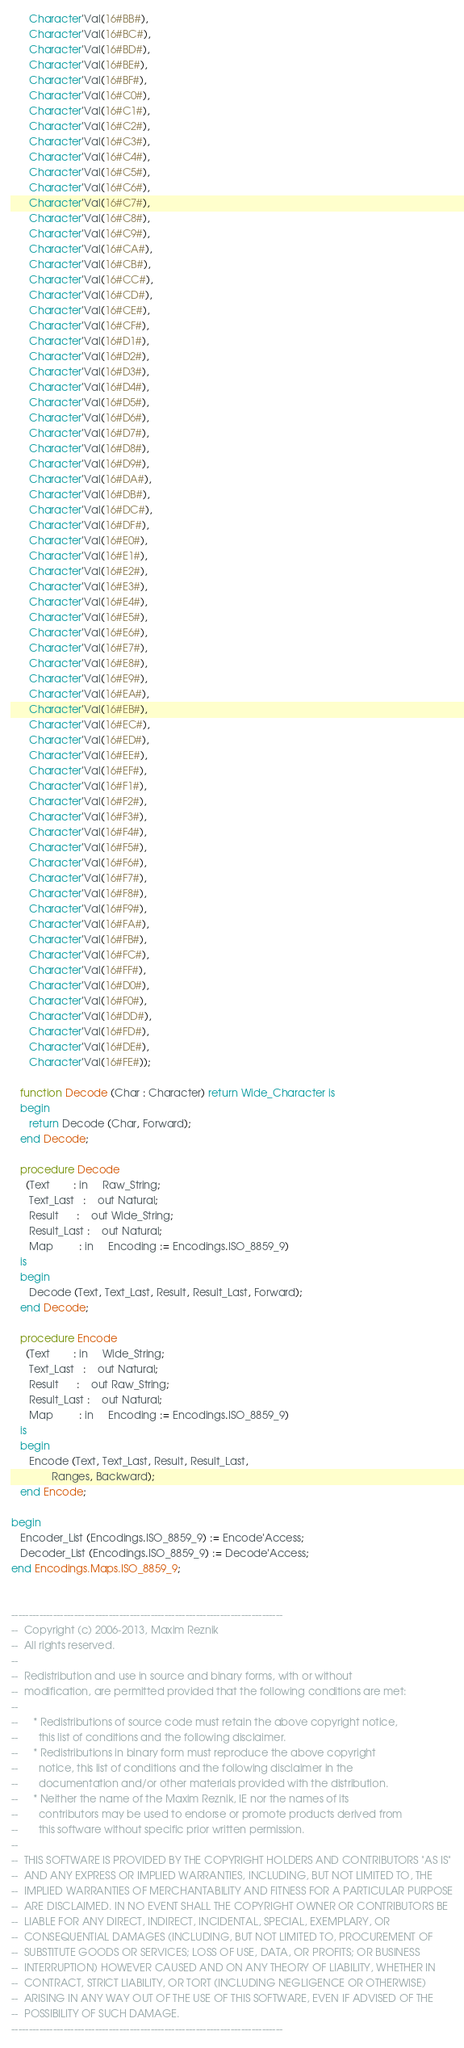Convert code to text. <code><loc_0><loc_0><loc_500><loc_500><_Ada_>      Character'Val(16#BB#),
      Character'Val(16#BC#),
      Character'Val(16#BD#),
      Character'Val(16#BE#),
      Character'Val(16#BF#),
      Character'Val(16#C0#),
      Character'Val(16#C1#),
      Character'Val(16#C2#),
      Character'Val(16#C3#),
      Character'Val(16#C4#),
      Character'Val(16#C5#),
      Character'Val(16#C6#),
      Character'Val(16#C7#),
      Character'Val(16#C8#),
      Character'Val(16#C9#),
      Character'Val(16#CA#),
      Character'Val(16#CB#),
      Character'Val(16#CC#),
      Character'Val(16#CD#),
      Character'Val(16#CE#),
      Character'Val(16#CF#),
      Character'Val(16#D1#),
      Character'Val(16#D2#),
      Character'Val(16#D3#),
      Character'Val(16#D4#),
      Character'Val(16#D5#),
      Character'Val(16#D6#),
      Character'Val(16#D7#),
      Character'Val(16#D8#),
      Character'Val(16#D9#),
      Character'Val(16#DA#),
      Character'Val(16#DB#),
      Character'Val(16#DC#),
      Character'Val(16#DF#),
      Character'Val(16#E0#),
      Character'Val(16#E1#),
      Character'Val(16#E2#),
      Character'Val(16#E3#),
      Character'Val(16#E4#),
      Character'Val(16#E5#),
      Character'Val(16#E6#),
      Character'Val(16#E7#),
      Character'Val(16#E8#),
      Character'Val(16#E9#),
      Character'Val(16#EA#),
      Character'Val(16#EB#),
      Character'Val(16#EC#),
      Character'Val(16#ED#),
      Character'Val(16#EE#),
      Character'Val(16#EF#),
      Character'Val(16#F1#),
      Character'Val(16#F2#),
      Character'Val(16#F3#),
      Character'Val(16#F4#),
      Character'Val(16#F5#),
      Character'Val(16#F6#),
      Character'Val(16#F7#),
      Character'Val(16#F8#),
      Character'Val(16#F9#),
      Character'Val(16#FA#),
      Character'Val(16#FB#),
      Character'Val(16#FC#),
      Character'Val(16#FF#),
      Character'Val(16#D0#),
      Character'Val(16#F0#),
      Character'Val(16#DD#),
      Character'Val(16#FD#),
      Character'Val(16#DE#),
      Character'Val(16#FE#));

   function Decode (Char : Character) return Wide_Character is
   begin
      return Decode (Char, Forward);
   end Decode;

   procedure Decode
     (Text        : in     Raw_String;
      Text_Last   :    out Natural;
      Result      :    out Wide_String;
      Result_Last :    out Natural;
      Map         : in     Encoding := Encodings.ISO_8859_9)
   is
   begin
      Decode (Text, Text_Last, Result, Result_Last, Forward);
   end Decode;

   procedure Encode
     (Text        : in     Wide_String;
      Text_Last   :    out Natural;
      Result      :    out Raw_String;
      Result_Last :    out Natural;
      Map         : in     Encoding := Encodings.ISO_8859_9)
   is
   begin
      Encode (Text, Text_Last, Result, Result_Last,
              Ranges, Backward);
   end Encode;

begin
   Encoder_List (Encodings.ISO_8859_9) := Encode'Access;
   Decoder_List (Encodings.ISO_8859_9) := Decode'Access;
end Encodings.Maps.ISO_8859_9;


------------------------------------------------------------------------------
--  Copyright (c) 2006-2013, Maxim Reznik
--  All rights reserved.
--
--  Redistribution and use in source and binary forms, with or without
--  modification, are permitted provided that the following conditions are met:
--
--     * Redistributions of source code must retain the above copyright notice,
--       this list of conditions and the following disclaimer.
--     * Redistributions in binary form must reproduce the above copyright
--       notice, this list of conditions and the following disclaimer in the
--       documentation and/or other materials provided with the distribution.
--     * Neither the name of the Maxim Reznik, IE nor the names of its
--       contributors may be used to endorse or promote products derived from
--       this software without specific prior written permission.
--
--  THIS SOFTWARE IS PROVIDED BY THE COPYRIGHT HOLDERS AND CONTRIBUTORS "AS IS"
--  AND ANY EXPRESS OR IMPLIED WARRANTIES, INCLUDING, BUT NOT LIMITED TO, THE
--  IMPLIED WARRANTIES OF MERCHANTABILITY AND FITNESS FOR A PARTICULAR PURPOSE
--  ARE DISCLAIMED. IN NO EVENT SHALL THE COPYRIGHT OWNER OR CONTRIBUTORS BE
--  LIABLE FOR ANY DIRECT, INDIRECT, INCIDENTAL, SPECIAL, EXEMPLARY, OR
--  CONSEQUENTIAL DAMAGES (INCLUDING, BUT NOT LIMITED TO, PROCUREMENT OF
--  SUBSTITUTE GOODS OR SERVICES; LOSS OF USE, DATA, OR PROFITS; OR BUSINESS
--  INTERRUPTION) HOWEVER CAUSED AND ON ANY THEORY OF LIABILITY, WHETHER IN
--  CONTRACT, STRICT LIABILITY, OR TORT (INCLUDING NEGLIGENCE OR OTHERWISE)
--  ARISING IN ANY WAY OUT OF THE USE OF THIS SOFTWARE, EVEN IF ADVISED OF THE
--  POSSIBILITY OF SUCH DAMAGE.
------------------------------------------------------------------------------
</code> 